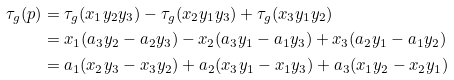Convert formula to latex. <formula><loc_0><loc_0><loc_500><loc_500>\tau _ { g } ( p ) & = \tau _ { g } ( x _ { 1 } y _ { 2 } y _ { 3 } ) - \tau _ { g } ( x _ { 2 } y _ { 1 } y _ { 3 } ) + \tau _ { g } ( x _ { 3 } y _ { 1 } y _ { 2 } ) \\ & = x _ { 1 } ( a _ { 3 } y _ { 2 } - a _ { 2 } y _ { 3 } ) - x _ { 2 } ( a _ { 3 } y _ { 1 } - a _ { 1 } y _ { 3 } ) + x _ { 3 } ( a _ { 2 } y _ { 1 } - a _ { 1 } y _ { 2 } ) \\ & = a _ { 1 } ( x _ { 2 } y _ { 3 } - x _ { 3 } y _ { 2 } ) + a _ { 2 } ( x _ { 3 } y _ { 1 } - x _ { 1 } y _ { 3 } ) + a _ { 3 } ( x _ { 1 } y _ { 2 } - x _ { 2 } y _ { 1 } )</formula> 